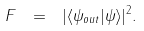<formula> <loc_0><loc_0><loc_500><loc_500>F \ = \ | \langle \psi _ { o u t } | \psi \rangle | ^ { 2 } .</formula> 